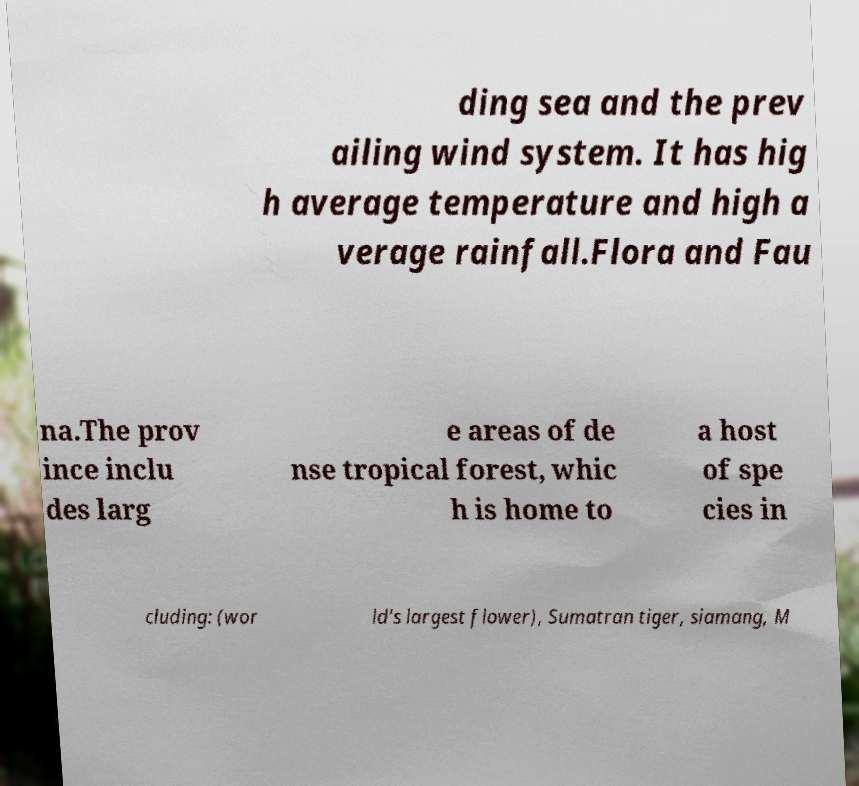Please identify and transcribe the text found in this image. ding sea and the prev ailing wind system. It has hig h average temperature and high a verage rainfall.Flora and Fau na.The prov ince inclu des larg e areas of de nse tropical forest, whic h is home to a host of spe cies in cluding: (wor ld's largest flower), Sumatran tiger, siamang, M 